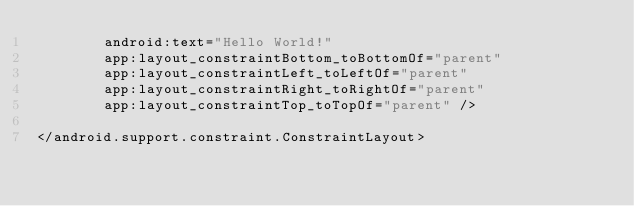Convert code to text. <code><loc_0><loc_0><loc_500><loc_500><_XML_>        android:text="Hello World!"
        app:layout_constraintBottom_toBottomOf="parent"
        app:layout_constraintLeft_toLeftOf="parent"
        app:layout_constraintRight_toRightOf="parent"
        app:layout_constraintTop_toTopOf="parent" />

</android.support.constraint.ConstraintLayout>
</code> 